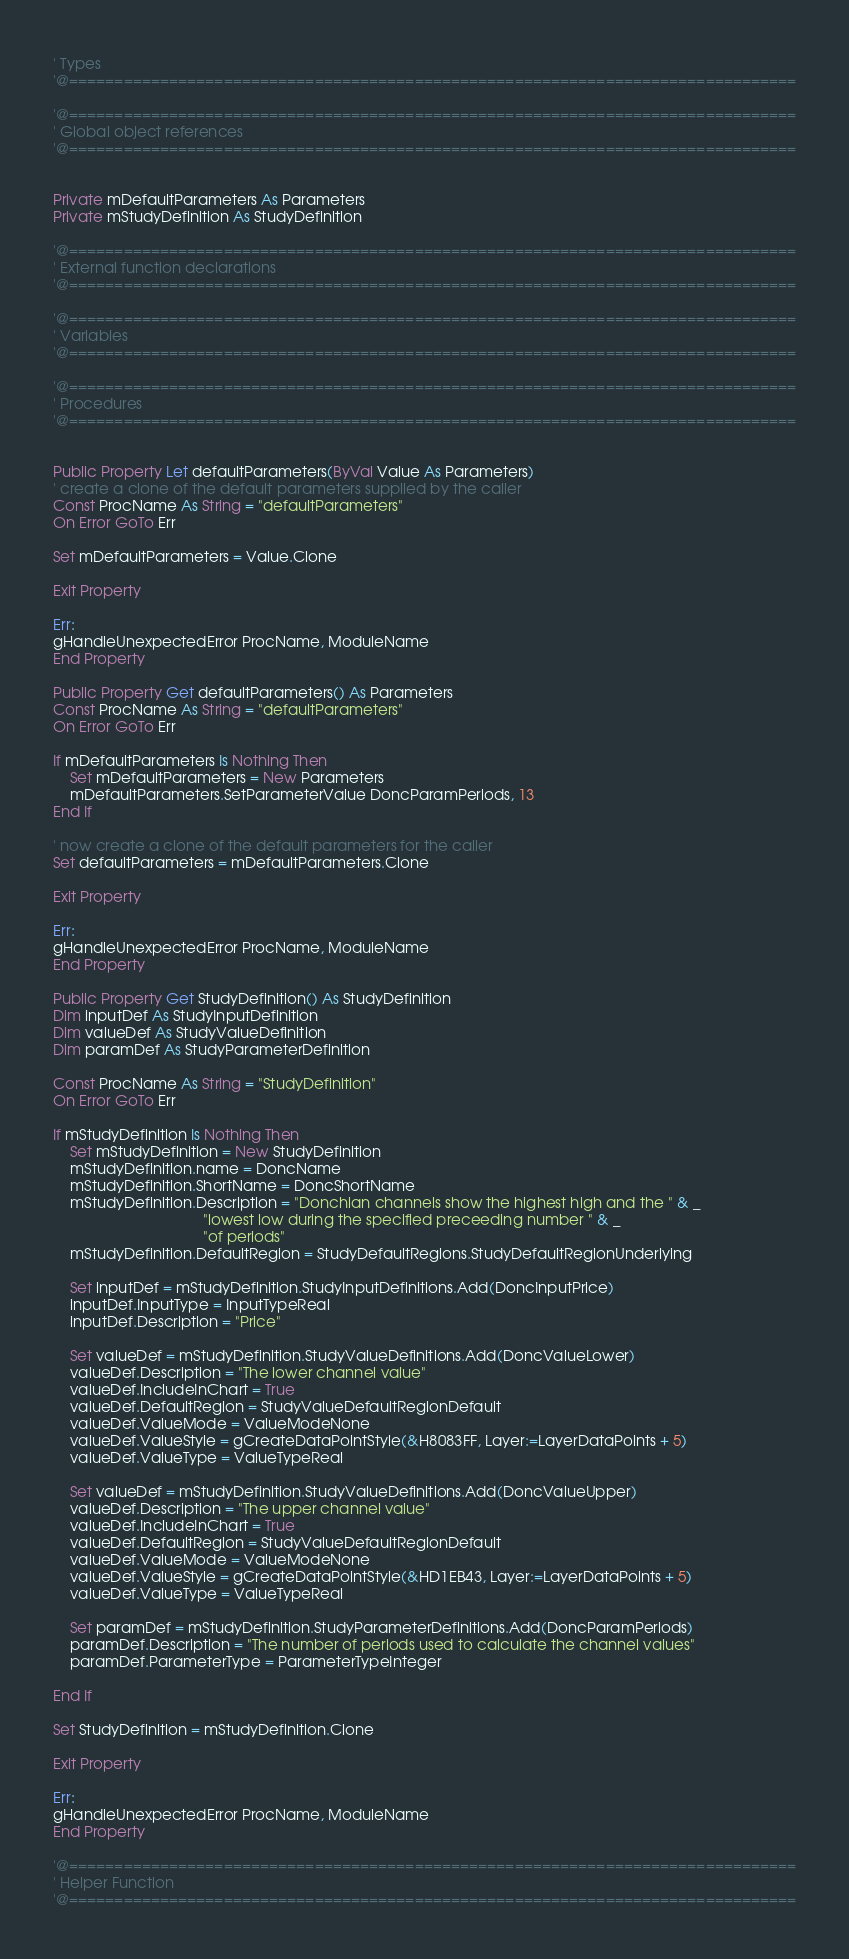<code> <loc_0><loc_0><loc_500><loc_500><_VisualBasic_>' Types
'@================================================================================

'@================================================================================
' Global object references
'@================================================================================


Private mDefaultParameters As Parameters
Private mStudyDefinition As StudyDefinition

'@================================================================================
' External function declarations
'@================================================================================

'@================================================================================
' Variables
'@================================================================================

'@================================================================================
' Procedures
'@================================================================================


Public Property Let defaultParameters(ByVal Value As Parameters)
' create a clone of the default parameters supplied by the caller
Const ProcName As String = "defaultParameters"
On Error GoTo Err

Set mDefaultParameters = Value.Clone

Exit Property

Err:
gHandleUnexpectedError ProcName, ModuleName
End Property

Public Property Get defaultParameters() As Parameters
Const ProcName As String = "defaultParameters"
On Error GoTo Err

If mDefaultParameters Is Nothing Then
    Set mDefaultParameters = New Parameters
    mDefaultParameters.SetParameterValue DoncParamPeriods, 13
End If

' now create a clone of the default parameters for the caller
Set defaultParameters = mDefaultParameters.Clone

Exit Property

Err:
gHandleUnexpectedError ProcName, ModuleName
End Property

Public Property Get StudyDefinition() As StudyDefinition
Dim inputDef As StudyInputDefinition
Dim valueDef As StudyValueDefinition
Dim paramDef As StudyParameterDefinition

Const ProcName As String = "StudyDefinition"
On Error GoTo Err

If mStudyDefinition Is Nothing Then
    Set mStudyDefinition = New StudyDefinition
    mStudyDefinition.name = DoncName
    mStudyDefinition.ShortName = DoncShortName
    mStudyDefinition.Description = "Donchian channels show the highest high and the " & _
                                    "lowest low during the specified preceeding number " & _
                                    "of periods"
    mStudyDefinition.DefaultRegion = StudyDefaultRegions.StudyDefaultRegionUnderlying
    
    Set inputDef = mStudyDefinition.StudyInputDefinitions.Add(DoncInputPrice)
    inputDef.InputType = InputTypeReal
    inputDef.Description = "Price"
    
    Set valueDef = mStudyDefinition.StudyValueDefinitions.Add(DoncValueLower)
    valueDef.Description = "The lower channel value"
    valueDef.IncludeInChart = True
    valueDef.DefaultRegion = StudyValueDefaultRegionDefault
    valueDef.ValueMode = ValueModeNone
    valueDef.ValueStyle = gCreateDataPointStyle(&H8083FF, Layer:=LayerDataPoints + 5)
    valueDef.ValueType = ValueTypeReal
    
    Set valueDef = mStudyDefinition.StudyValueDefinitions.Add(DoncValueUpper)
    valueDef.Description = "The upper channel value"
    valueDef.IncludeInChart = True
    valueDef.DefaultRegion = StudyValueDefaultRegionDefault
    valueDef.ValueMode = ValueModeNone
    valueDef.ValueStyle = gCreateDataPointStyle(&HD1EB43, Layer:=LayerDataPoints + 5)
    valueDef.ValueType = ValueTypeReal
    
    Set paramDef = mStudyDefinition.StudyParameterDefinitions.Add(DoncParamPeriods)
    paramDef.Description = "The number of periods used to calculate the channel values"
    paramDef.ParameterType = ParameterTypeInteger

End If

Set StudyDefinition = mStudyDefinition.Clone

Exit Property

Err:
gHandleUnexpectedError ProcName, ModuleName
End Property

'@================================================================================
' Helper Function
'@================================================================================





</code> 